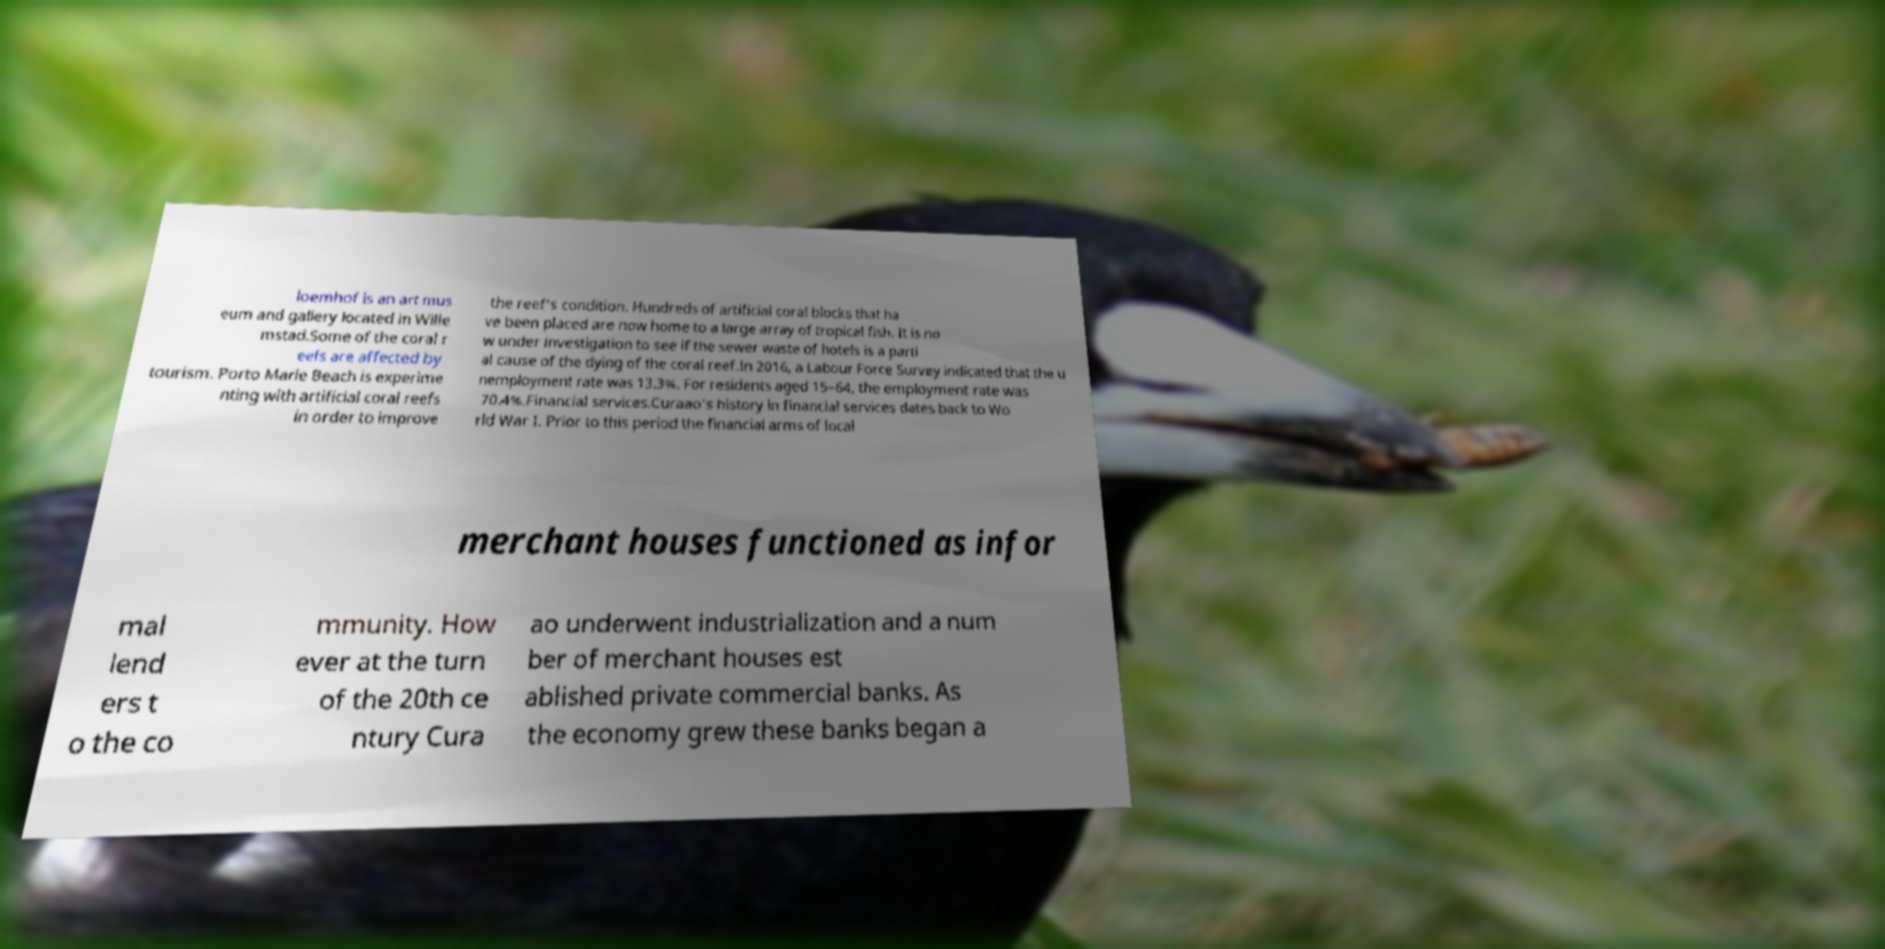What messages or text are displayed in this image? I need them in a readable, typed format. loemhof is an art mus eum and gallery located in Wille mstad.Some of the coral r eefs are affected by tourism. Porto Marie Beach is experime nting with artificial coral reefs in order to improve the reef's condition. Hundreds of artificial coral blocks that ha ve been placed are now home to a large array of tropical fish. It is no w under investigation to see if the sewer waste of hotels is a parti al cause of the dying of the coral reef.In 2016, a Labour Force Survey indicated that the u nemployment rate was 13.3%. For residents aged 15–64, the employment rate was 70.4%.Financial services.Curaao's history in financial services dates back to Wo rld War I. Prior to this period the financial arms of local merchant houses functioned as infor mal lend ers t o the co mmunity. How ever at the turn of the 20th ce ntury Cura ao underwent industrialization and a num ber of merchant houses est ablished private commercial banks. As the economy grew these banks began a 